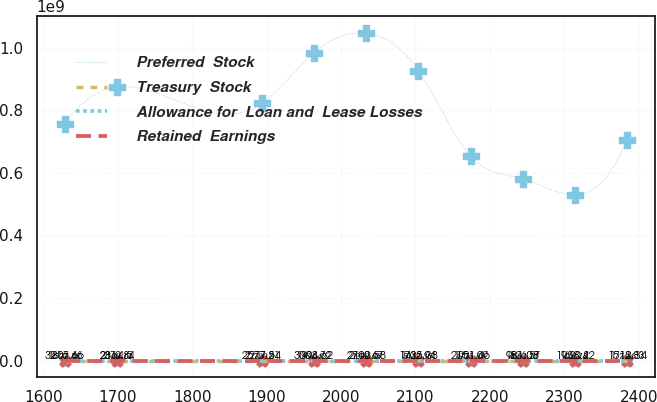<chart> <loc_0><loc_0><loc_500><loc_500><line_chart><ecel><fcel>Preferred  Stock<fcel>Treasury  Stock<fcel>Allowance for  Loan and  Lease Losses<fcel>Retained  Earnings<nl><fcel>1628.8<fcel>7.56506e+08<fcel>1807.46<fcel>2577.38<fcel>3216.66<nl><fcel>1698.84<fcel>8.73954e+08<fcel>2370.84<fcel>2149.14<fcel>2364.5<nl><fcel>1893.82<fcel>8.22335e+08<fcel>2277.21<fcel>1720.9<fcel>2577.54<nl><fcel>1963.86<fcel>9.84039e+08<fcel>1994.72<fcel>864.42<fcel>3003.62<nl><fcel>2033.89<fcel>1.04581e+09<fcel>2169.67<fcel>1292.66<fcel>2790.58<nl><fcel>2103.93<fcel>9.25572e+08<fcel>1432.94<fcel>5032.36<fcel>1725.38<nl><fcel>2173.96<fcel>6.53269e+08<fcel>1901.09<fcel>4175.88<fcel>2151.46<nl><fcel>2243.99<fcel>5.81244e+08<fcel>1526.57<fcel>4604.12<fcel>981.08<nl><fcel>2314.02<fcel>5.29626e+08<fcel>1620.2<fcel>436.18<fcel>1938.42<nl><fcel>2384.05<fcel>7.04888e+08<fcel>1713.83<fcel>7.94<fcel>1512.34<nl></chart> 